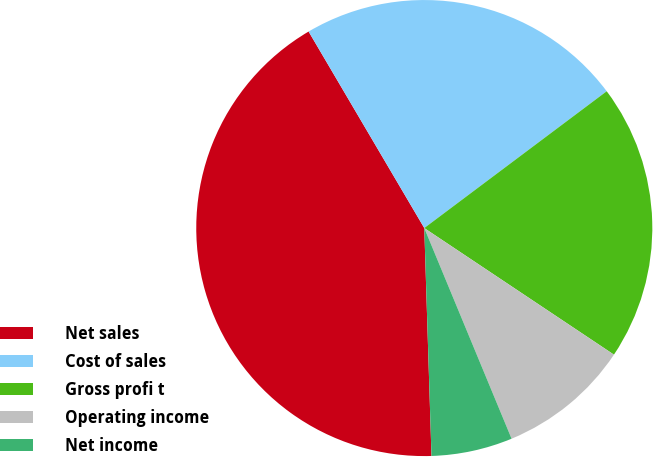Convert chart. <chart><loc_0><loc_0><loc_500><loc_500><pie_chart><fcel>Net sales<fcel>Cost of sales<fcel>Gross profi t<fcel>Operating income<fcel>Net income<nl><fcel>42.04%<fcel>23.23%<fcel>19.61%<fcel>9.38%<fcel>5.75%<nl></chart> 